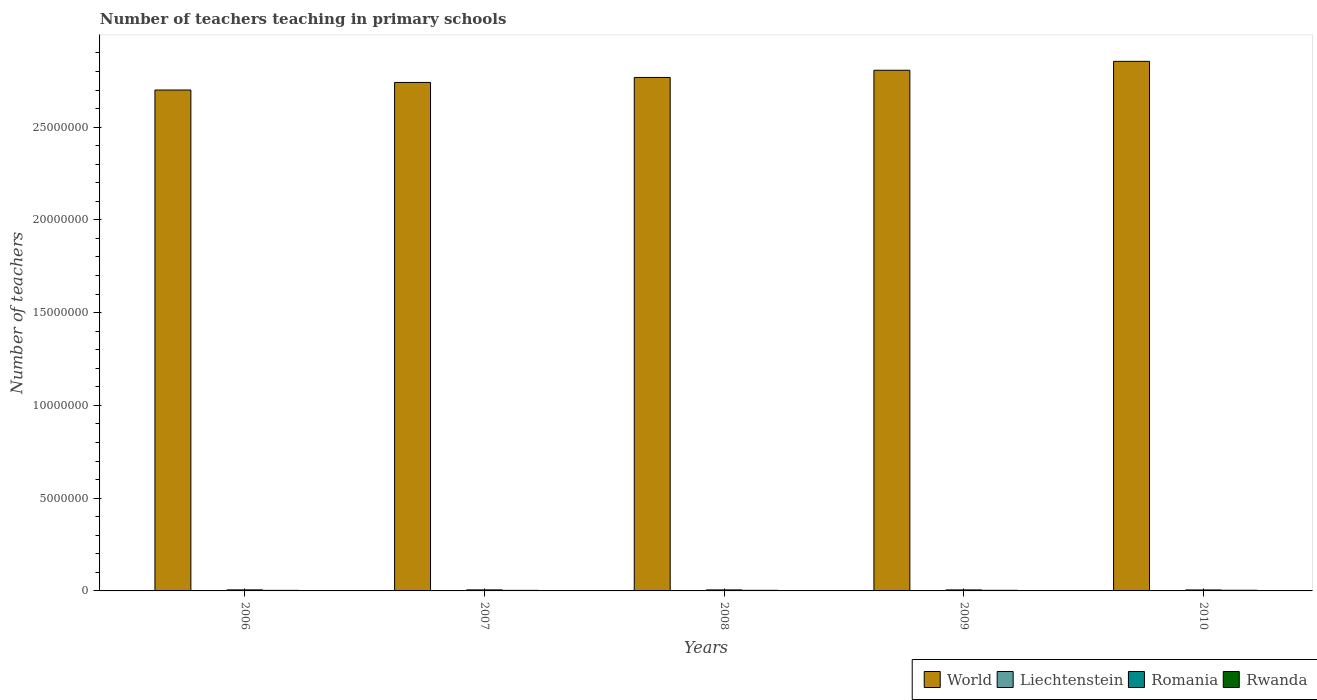How many different coloured bars are there?
Keep it short and to the point. 4. Are the number of bars per tick equal to the number of legend labels?
Your answer should be compact. Yes. Are the number of bars on each tick of the X-axis equal?
Your answer should be compact. Yes. How many bars are there on the 5th tick from the right?
Provide a succinct answer. 4. In how many cases, is the number of bars for a given year not equal to the number of legend labels?
Make the answer very short. 0. What is the number of teachers teaching in primary schools in Romania in 2009?
Provide a short and direct response. 5.41e+04. Across all years, what is the maximum number of teachers teaching in primary schools in Rwanda?
Give a very brief answer. 3.56e+04. Across all years, what is the minimum number of teachers teaching in primary schools in Liechtenstein?
Offer a terse response. 268. What is the total number of teachers teaching in primary schools in Romania in the graph?
Make the answer very short. 2.72e+05. What is the difference between the number of teachers teaching in primary schools in Romania in 2006 and that in 2007?
Make the answer very short. 334. What is the difference between the number of teachers teaching in primary schools in World in 2008 and the number of teachers teaching in primary schools in Liechtenstein in 2006?
Provide a short and direct response. 2.77e+07. What is the average number of teachers teaching in primary schools in Romania per year?
Keep it short and to the point. 5.44e+04. In the year 2007, what is the difference between the number of teachers teaching in primary schools in Liechtenstein and number of teachers teaching in primary schools in World?
Provide a succinct answer. -2.74e+07. In how many years, is the number of teachers teaching in primary schools in World greater than 25000000?
Keep it short and to the point. 5. What is the ratio of the number of teachers teaching in primary schools in World in 2007 to that in 2008?
Provide a succinct answer. 0.99. What is the difference between the highest and the second highest number of teachers teaching in primary schools in World?
Offer a terse response. 4.80e+05. What is the difference between the highest and the lowest number of teachers teaching in primary schools in Rwanda?
Your answer should be compact. 4946. What does the 3rd bar from the left in 2010 represents?
Offer a very short reply. Romania. Is it the case that in every year, the sum of the number of teachers teaching in primary schools in Romania and number of teachers teaching in primary schools in Rwanda is greater than the number of teachers teaching in primary schools in World?
Your answer should be very brief. No. How many bars are there?
Provide a succinct answer. 20. Are all the bars in the graph horizontal?
Your answer should be very brief. No. How many years are there in the graph?
Ensure brevity in your answer.  5. What is the difference between two consecutive major ticks on the Y-axis?
Your response must be concise. 5.00e+06. Does the graph contain any zero values?
Keep it short and to the point. No. Does the graph contain grids?
Your answer should be very brief. No. Where does the legend appear in the graph?
Offer a terse response. Bottom right. How are the legend labels stacked?
Make the answer very short. Horizontal. What is the title of the graph?
Keep it short and to the point. Number of teachers teaching in primary schools. Does "Congo (Democratic)" appear as one of the legend labels in the graph?
Provide a short and direct response. No. What is the label or title of the X-axis?
Give a very brief answer. Years. What is the label or title of the Y-axis?
Your answer should be very brief. Number of teachers. What is the Number of teachers of World in 2006?
Make the answer very short. 2.70e+07. What is the Number of teachers in Liechtenstein in 2006?
Keep it short and to the point. 268. What is the Number of teachers in Romania in 2006?
Provide a short and direct response. 5.58e+04. What is the Number of teachers of Rwanda in 2006?
Your answer should be very brief. 3.06e+04. What is the Number of teachers in World in 2007?
Keep it short and to the point. 2.74e+07. What is the Number of teachers in Liechtenstein in 2007?
Provide a short and direct response. 315. What is the Number of teachers in Romania in 2007?
Keep it short and to the point. 5.55e+04. What is the Number of teachers of Rwanda in 2007?
Provide a short and direct response. 3.10e+04. What is the Number of teachers of World in 2008?
Offer a terse response. 2.77e+07. What is the Number of teachers in Liechtenstein in 2008?
Keep it short and to the point. 332. What is the Number of teachers of Romania in 2008?
Ensure brevity in your answer.  5.46e+04. What is the Number of teachers of Rwanda in 2008?
Your answer should be compact. 3.23e+04. What is the Number of teachers in World in 2009?
Your response must be concise. 2.81e+07. What is the Number of teachers of Liechtenstein in 2009?
Keep it short and to the point. 328. What is the Number of teachers in Romania in 2009?
Offer a very short reply. 5.41e+04. What is the Number of teachers of Rwanda in 2009?
Your answer should be compact. 3.32e+04. What is the Number of teachers of World in 2010?
Provide a short and direct response. 2.85e+07. What is the Number of teachers of Liechtenstein in 2010?
Provide a succinct answer. 337. What is the Number of teachers of Romania in 2010?
Your answer should be very brief. 5.23e+04. What is the Number of teachers in Rwanda in 2010?
Offer a terse response. 3.56e+04. Across all years, what is the maximum Number of teachers of World?
Provide a succinct answer. 2.85e+07. Across all years, what is the maximum Number of teachers of Liechtenstein?
Give a very brief answer. 337. Across all years, what is the maximum Number of teachers of Romania?
Give a very brief answer. 5.58e+04. Across all years, what is the maximum Number of teachers in Rwanda?
Give a very brief answer. 3.56e+04. Across all years, what is the minimum Number of teachers in World?
Ensure brevity in your answer.  2.70e+07. Across all years, what is the minimum Number of teachers in Liechtenstein?
Ensure brevity in your answer.  268. Across all years, what is the minimum Number of teachers in Romania?
Your answer should be compact. 5.23e+04. Across all years, what is the minimum Number of teachers in Rwanda?
Provide a succinct answer. 3.06e+04. What is the total Number of teachers in World in the graph?
Ensure brevity in your answer.  1.39e+08. What is the total Number of teachers in Liechtenstein in the graph?
Keep it short and to the point. 1580. What is the total Number of teachers of Romania in the graph?
Offer a terse response. 2.72e+05. What is the total Number of teachers of Rwanda in the graph?
Your answer should be very brief. 1.63e+05. What is the difference between the Number of teachers in World in 2006 and that in 2007?
Offer a very short reply. -4.08e+05. What is the difference between the Number of teachers of Liechtenstein in 2006 and that in 2007?
Provide a succinct answer. -47. What is the difference between the Number of teachers in Romania in 2006 and that in 2007?
Keep it short and to the point. 334. What is the difference between the Number of teachers in Rwanda in 2006 and that in 2007?
Provide a succinct answer. -400. What is the difference between the Number of teachers of World in 2006 and that in 2008?
Provide a succinct answer. -6.77e+05. What is the difference between the Number of teachers in Liechtenstein in 2006 and that in 2008?
Your answer should be compact. -64. What is the difference between the Number of teachers in Romania in 2006 and that in 2008?
Offer a very short reply. 1271. What is the difference between the Number of teachers of Rwanda in 2006 and that in 2008?
Give a very brief answer. -1701. What is the difference between the Number of teachers in World in 2006 and that in 2009?
Provide a short and direct response. -1.06e+06. What is the difference between the Number of teachers of Liechtenstein in 2006 and that in 2009?
Ensure brevity in your answer.  -60. What is the difference between the Number of teachers in Romania in 2006 and that in 2009?
Keep it short and to the point. 1752. What is the difference between the Number of teachers of Rwanda in 2006 and that in 2009?
Keep it short and to the point. -2521. What is the difference between the Number of teachers in World in 2006 and that in 2010?
Ensure brevity in your answer.  -1.55e+06. What is the difference between the Number of teachers in Liechtenstein in 2006 and that in 2010?
Ensure brevity in your answer.  -69. What is the difference between the Number of teachers in Romania in 2006 and that in 2010?
Ensure brevity in your answer.  3549. What is the difference between the Number of teachers in Rwanda in 2006 and that in 2010?
Offer a terse response. -4946. What is the difference between the Number of teachers in World in 2007 and that in 2008?
Give a very brief answer. -2.69e+05. What is the difference between the Number of teachers of Romania in 2007 and that in 2008?
Give a very brief answer. 937. What is the difference between the Number of teachers of Rwanda in 2007 and that in 2008?
Keep it short and to the point. -1301. What is the difference between the Number of teachers in World in 2007 and that in 2009?
Offer a very short reply. -6.57e+05. What is the difference between the Number of teachers of Romania in 2007 and that in 2009?
Keep it short and to the point. 1418. What is the difference between the Number of teachers of Rwanda in 2007 and that in 2009?
Keep it short and to the point. -2121. What is the difference between the Number of teachers of World in 2007 and that in 2010?
Your answer should be compact. -1.14e+06. What is the difference between the Number of teachers of Liechtenstein in 2007 and that in 2010?
Your answer should be compact. -22. What is the difference between the Number of teachers in Romania in 2007 and that in 2010?
Keep it short and to the point. 3215. What is the difference between the Number of teachers in Rwanda in 2007 and that in 2010?
Provide a succinct answer. -4546. What is the difference between the Number of teachers of World in 2008 and that in 2009?
Your answer should be very brief. -3.88e+05. What is the difference between the Number of teachers in Liechtenstein in 2008 and that in 2009?
Provide a succinct answer. 4. What is the difference between the Number of teachers of Romania in 2008 and that in 2009?
Keep it short and to the point. 481. What is the difference between the Number of teachers of Rwanda in 2008 and that in 2009?
Offer a very short reply. -820. What is the difference between the Number of teachers in World in 2008 and that in 2010?
Offer a very short reply. -8.69e+05. What is the difference between the Number of teachers in Romania in 2008 and that in 2010?
Offer a very short reply. 2278. What is the difference between the Number of teachers in Rwanda in 2008 and that in 2010?
Provide a succinct answer. -3245. What is the difference between the Number of teachers in World in 2009 and that in 2010?
Provide a short and direct response. -4.80e+05. What is the difference between the Number of teachers of Romania in 2009 and that in 2010?
Offer a very short reply. 1797. What is the difference between the Number of teachers in Rwanda in 2009 and that in 2010?
Make the answer very short. -2425. What is the difference between the Number of teachers in World in 2006 and the Number of teachers in Liechtenstein in 2007?
Make the answer very short. 2.70e+07. What is the difference between the Number of teachers of World in 2006 and the Number of teachers of Romania in 2007?
Ensure brevity in your answer.  2.69e+07. What is the difference between the Number of teachers in World in 2006 and the Number of teachers in Rwanda in 2007?
Give a very brief answer. 2.70e+07. What is the difference between the Number of teachers in Liechtenstein in 2006 and the Number of teachers in Romania in 2007?
Your response must be concise. -5.52e+04. What is the difference between the Number of teachers of Liechtenstein in 2006 and the Number of teachers of Rwanda in 2007?
Ensure brevity in your answer.  -3.08e+04. What is the difference between the Number of teachers in Romania in 2006 and the Number of teachers in Rwanda in 2007?
Give a very brief answer. 2.48e+04. What is the difference between the Number of teachers of World in 2006 and the Number of teachers of Liechtenstein in 2008?
Keep it short and to the point. 2.70e+07. What is the difference between the Number of teachers of World in 2006 and the Number of teachers of Romania in 2008?
Your response must be concise. 2.69e+07. What is the difference between the Number of teachers of World in 2006 and the Number of teachers of Rwanda in 2008?
Make the answer very short. 2.70e+07. What is the difference between the Number of teachers of Liechtenstein in 2006 and the Number of teachers of Romania in 2008?
Your response must be concise. -5.43e+04. What is the difference between the Number of teachers in Liechtenstein in 2006 and the Number of teachers in Rwanda in 2008?
Offer a terse response. -3.21e+04. What is the difference between the Number of teachers of Romania in 2006 and the Number of teachers of Rwanda in 2008?
Give a very brief answer. 2.35e+04. What is the difference between the Number of teachers of World in 2006 and the Number of teachers of Liechtenstein in 2009?
Ensure brevity in your answer.  2.70e+07. What is the difference between the Number of teachers in World in 2006 and the Number of teachers in Romania in 2009?
Your answer should be compact. 2.69e+07. What is the difference between the Number of teachers in World in 2006 and the Number of teachers in Rwanda in 2009?
Your answer should be compact. 2.70e+07. What is the difference between the Number of teachers in Liechtenstein in 2006 and the Number of teachers in Romania in 2009?
Ensure brevity in your answer.  -5.38e+04. What is the difference between the Number of teachers in Liechtenstein in 2006 and the Number of teachers in Rwanda in 2009?
Keep it short and to the point. -3.29e+04. What is the difference between the Number of teachers of Romania in 2006 and the Number of teachers of Rwanda in 2009?
Keep it short and to the point. 2.27e+04. What is the difference between the Number of teachers in World in 2006 and the Number of teachers in Liechtenstein in 2010?
Offer a terse response. 2.70e+07. What is the difference between the Number of teachers of World in 2006 and the Number of teachers of Romania in 2010?
Provide a succinct answer. 2.69e+07. What is the difference between the Number of teachers in World in 2006 and the Number of teachers in Rwanda in 2010?
Provide a short and direct response. 2.70e+07. What is the difference between the Number of teachers of Liechtenstein in 2006 and the Number of teachers of Romania in 2010?
Your answer should be very brief. -5.20e+04. What is the difference between the Number of teachers of Liechtenstein in 2006 and the Number of teachers of Rwanda in 2010?
Your response must be concise. -3.53e+04. What is the difference between the Number of teachers in Romania in 2006 and the Number of teachers in Rwanda in 2010?
Your answer should be very brief. 2.02e+04. What is the difference between the Number of teachers in World in 2007 and the Number of teachers in Liechtenstein in 2008?
Provide a succinct answer. 2.74e+07. What is the difference between the Number of teachers of World in 2007 and the Number of teachers of Romania in 2008?
Your answer should be compact. 2.74e+07. What is the difference between the Number of teachers of World in 2007 and the Number of teachers of Rwanda in 2008?
Your answer should be very brief. 2.74e+07. What is the difference between the Number of teachers of Liechtenstein in 2007 and the Number of teachers of Romania in 2008?
Provide a short and direct response. -5.42e+04. What is the difference between the Number of teachers in Liechtenstein in 2007 and the Number of teachers in Rwanda in 2008?
Offer a terse response. -3.20e+04. What is the difference between the Number of teachers of Romania in 2007 and the Number of teachers of Rwanda in 2008?
Your answer should be very brief. 2.31e+04. What is the difference between the Number of teachers in World in 2007 and the Number of teachers in Liechtenstein in 2009?
Keep it short and to the point. 2.74e+07. What is the difference between the Number of teachers in World in 2007 and the Number of teachers in Romania in 2009?
Ensure brevity in your answer.  2.74e+07. What is the difference between the Number of teachers of World in 2007 and the Number of teachers of Rwanda in 2009?
Make the answer very short. 2.74e+07. What is the difference between the Number of teachers in Liechtenstein in 2007 and the Number of teachers in Romania in 2009?
Your answer should be very brief. -5.38e+04. What is the difference between the Number of teachers in Liechtenstein in 2007 and the Number of teachers in Rwanda in 2009?
Your answer should be very brief. -3.28e+04. What is the difference between the Number of teachers of Romania in 2007 and the Number of teachers of Rwanda in 2009?
Ensure brevity in your answer.  2.23e+04. What is the difference between the Number of teachers of World in 2007 and the Number of teachers of Liechtenstein in 2010?
Ensure brevity in your answer.  2.74e+07. What is the difference between the Number of teachers of World in 2007 and the Number of teachers of Romania in 2010?
Your response must be concise. 2.74e+07. What is the difference between the Number of teachers in World in 2007 and the Number of teachers in Rwanda in 2010?
Ensure brevity in your answer.  2.74e+07. What is the difference between the Number of teachers in Liechtenstein in 2007 and the Number of teachers in Romania in 2010?
Your answer should be compact. -5.20e+04. What is the difference between the Number of teachers of Liechtenstein in 2007 and the Number of teachers of Rwanda in 2010?
Give a very brief answer. -3.53e+04. What is the difference between the Number of teachers in Romania in 2007 and the Number of teachers in Rwanda in 2010?
Offer a terse response. 1.99e+04. What is the difference between the Number of teachers of World in 2008 and the Number of teachers of Liechtenstein in 2009?
Make the answer very short. 2.77e+07. What is the difference between the Number of teachers in World in 2008 and the Number of teachers in Romania in 2009?
Provide a succinct answer. 2.76e+07. What is the difference between the Number of teachers in World in 2008 and the Number of teachers in Rwanda in 2009?
Keep it short and to the point. 2.76e+07. What is the difference between the Number of teachers in Liechtenstein in 2008 and the Number of teachers in Romania in 2009?
Your response must be concise. -5.37e+04. What is the difference between the Number of teachers of Liechtenstein in 2008 and the Number of teachers of Rwanda in 2009?
Your answer should be very brief. -3.28e+04. What is the difference between the Number of teachers in Romania in 2008 and the Number of teachers in Rwanda in 2009?
Your answer should be compact. 2.14e+04. What is the difference between the Number of teachers in World in 2008 and the Number of teachers in Liechtenstein in 2010?
Provide a short and direct response. 2.77e+07. What is the difference between the Number of teachers of World in 2008 and the Number of teachers of Romania in 2010?
Ensure brevity in your answer.  2.76e+07. What is the difference between the Number of teachers in World in 2008 and the Number of teachers in Rwanda in 2010?
Offer a terse response. 2.76e+07. What is the difference between the Number of teachers of Liechtenstein in 2008 and the Number of teachers of Romania in 2010?
Provide a short and direct response. -5.19e+04. What is the difference between the Number of teachers in Liechtenstein in 2008 and the Number of teachers in Rwanda in 2010?
Give a very brief answer. -3.53e+04. What is the difference between the Number of teachers of Romania in 2008 and the Number of teachers of Rwanda in 2010?
Provide a short and direct response. 1.90e+04. What is the difference between the Number of teachers of World in 2009 and the Number of teachers of Liechtenstein in 2010?
Your answer should be very brief. 2.81e+07. What is the difference between the Number of teachers of World in 2009 and the Number of teachers of Romania in 2010?
Provide a short and direct response. 2.80e+07. What is the difference between the Number of teachers of World in 2009 and the Number of teachers of Rwanda in 2010?
Offer a terse response. 2.80e+07. What is the difference between the Number of teachers in Liechtenstein in 2009 and the Number of teachers in Romania in 2010?
Offer a very short reply. -5.19e+04. What is the difference between the Number of teachers in Liechtenstein in 2009 and the Number of teachers in Rwanda in 2010?
Ensure brevity in your answer.  -3.53e+04. What is the difference between the Number of teachers of Romania in 2009 and the Number of teachers of Rwanda in 2010?
Provide a short and direct response. 1.85e+04. What is the average Number of teachers in World per year?
Offer a terse response. 2.77e+07. What is the average Number of teachers of Liechtenstein per year?
Your answer should be very brief. 316. What is the average Number of teachers of Romania per year?
Keep it short and to the point. 5.44e+04. What is the average Number of teachers of Rwanda per year?
Your answer should be compact. 3.26e+04. In the year 2006, what is the difference between the Number of teachers of World and Number of teachers of Liechtenstein?
Your answer should be very brief. 2.70e+07. In the year 2006, what is the difference between the Number of teachers of World and Number of teachers of Romania?
Offer a terse response. 2.69e+07. In the year 2006, what is the difference between the Number of teachers of World and Number of teachers of Rwanda?
Offer a terse response. 2.70e+07. In the year 2006, what is the difference between the Number of teachers of Liechtenstein and Number of teachers of Romania?
Your answer should be compact. -5.56e+04. In the year 2006, what is the difference between the Number of teachers of Liechtenstein and Number of teachers of Rwanda?
Provide a succinct answer. -3.04e+04. In the year 2006, what is the difference between the Number of teachers of Romania and Number of teachers of Rwanda?
Your answer should be compact. 2.52e+04. In the year 2007, what is the difference between the Number of teachers in World and Number of teachers in Liechtenstein?
Offer a very short reply. 2.74e+07. In the year 2007, what is the difference between the Number of teachers in World and Number of teachers in Romania?
Provide a short and direct response. 2.74e+07. In the year 2007, what is the difference between the Number of teachers of World and Number of teachers of Rwanda?
Offer a terse response. 2.74e+07. In the year 2007, what is the difference between the Number of teachers in Liechtenstein and Number of teachers in Romania?
Your answer should be compact. -5.52e+04. In the year 2007, what is the difference between the Number of teachers in Liechtenstein and Number of teachers in Rwanda?
Offer a terse response. -3.07e+04. In the year 2007, what is the difference between the Number of teachers of Romania and Number of teachers of Rwanda?
Give a very brief answer. 2.44e+04. In the year 2008, what is the difference between the Number of teachers of World and Number of teachers of Liechtenstein?
Your response must be concise. 2.77e+07. In the year 2008, what is the difference between the Number of teachers of World and Number of teachers of Romania?
Offer a very short reply. 2.76e+07. In the year 2008, what is the difference between the Number of teachers in World and Number of teachers in Rwanda?
Your answer should be compact. 2.76e+07. In the year 2008, what is the difference between the Number of teachers of Liechtenstein and Number of teachers of Romania?
Your response must be concise. -5.42e+04. In the year 2008, what is the difference between the Number of teachers of Liechtenstein and Number of teachers of Rwanda?
Make the answer very short. -3.20e+04. In the year 2008, what is the difference between the Number of teachers in Romania and Number of teachers in Rwanda?
Keep it short and to the point. 2.22e+04. In the year 2009, what is the difference between the Number of teachers of World and Number of teachers of Liechtenstein?
Offer a very short reply. 2.81e+07. In the year 2009, what is the difference between the Number of teachers of World and Number of teachers of Romania?
Provide a succinct answer. 2.80e+07. In the year 2009, what is the difference between the Number of teachers in World and Number of teachers in Rwanda?
Give a very brief answer. 2.80e+07. In the year 2009, what is the difference between the Number of teachers in Liechtenstein and Number of teachers in Romania?
Offer a terse response. -5.37e+04. In the year 2009, what is the difference between the Number of teachers of Liechtenstein and Number of teachers of Rwanda?
Provide a succinct answer. -3.28e+04. In the year 2009, what is the difference between the Number of teachers in Romania and Number of teachers in Rwanda?
Offer a very short reply. 2.09e+04. In the year 2010, what is the difference between the Number of teachers of World and Number of teachers of Liechtenstein?
Offer a terse response. 2.85e+07. In the year 2010, what is the difference between the Number of teachers in World and Number of teachers in Romania?
Your answer should be very brief. 2.85e+07. In the year 2010, what is the difference between the Number of teachers in World and Number of teachers in Rwanda?
Offer a terse response. 2.85e+07. In the year 2010, what is the difference between the Number of teachers in Liechtenstein and Number of teachers in Romania?
Offer a very short reply. -5.19e+04. In the year 2010, what is the difference between the Number of teachers of Liechtenstein and Number of teachers of Rwanda?
Your answer should be compact. -3.52e+04. In the year 2010, what is the difference between the Number of teachers in Romania and Number of teachers in Rwanda?
Offer a terse response. 1.67e+04. What is the ratio of the Number of teachers in World in 2006 to that in 2007?
Keep it short and to the point. 0.99. What is the ratio of the Number of teachers of Liechtenstein in 2006 to that in 2007?
Your answer should be compact. 0.85. What is the ratio of the Number of teachers of Rwanda in 2006 to that in 2007?
Give a very brief answer. 0.99. What is the ratio of the Number of teachers in World in 2006 to that in 2008?
Ensure brevity in your answer.  0.98. What is the ratio of the Number of teachers in Liechtenstein in 2006 to that in 2008?
Offer a very short reply. 0.81. What is the ratio of the Number of teachers of Romania in 2006 to that in 2008?
Offer a terse response. 1.02. What is the ratio of the Number of teachers of World in 2006 to that in 2009?
Provide a succinct answer. 0.96. What is the ratio of the Number of teachers in Liechtenstein in 2006 to that in 2009?
Provide a short and direct response. 0.82. What is the ratio of the Number of teachers in Romania in 2006 to that in 2009?
Make the answer very short. 1.03. What is the ratio of the Number of teachers of Rwanda in 2006 to that in 2009?
Make the answer very short. 0.92. What is the ratio of the Number of teachers of World in 2006 to that in 2010?
Provide a succinct answer. 0.95. What is the ratio of the Number of teachers in Liechtenstein in 2006 to that in 2010?
Give a very brief answer. 0.8. What is the ratio of the Number of teachers in Romania in 2006 to that in 2010?
Keep it short and to the point. 1.07. What is the ratio of the Number of teachers in Rwanda in 2006 to that in 2010?
Your response must be concise. 0.86. What is the ratio of the Number of teachers of World in 2007 to that in 2008?
Your answer should be compact. 0.99. What is the ratio of the Number of teachers of Liechtenstein in 2007 to that in 2008?
Ensure brevity in your answer.  0.95. What is the ratio of the Number of teachers of Romania in 2007 to that in 2008?
Your answer should be very brief. 1.02. What is the ratio of the Number of teachers in Rwanda in 2007 to that in 2008?
Provide a short and direct response. 0.96. What is the ratio of the Number of teachers in World in 2007 to that in 2009?
Keep it short and to the point. 0.98. What is the ratio of the Number of teachers in Liechtenstein in 2007 to that in 2009?
Make the answer very short. 0.96. What is the ratio of the Number of teachers in Romania in 2007 to that in 2009?
Offer a terse response. 1.03. What is the ratio of the Number of teachers of Rwanda in 2007 to that in 2009?
Make the answer very short. 0.94. What is the ratio of the Number of teachers in World in 2007 to that in 2010?
Make the answer very short. 0.96. What is the ratio of the Number of teachers of Liechtenstein in 2007 to that in 2010?
Keep it short and to the point. 0.93. What is the ratio of the Number of teachers of Romania in 2007 to that in 2010?
Your response must be concise. 1.06. What is the ratio of the Number of teachers of Rwanda in 2007 to that in 2010?
Your response must be concise. 0.87. What is the ratio of the Number of teachers of World in 2008 to that in 2009?
Ensure brevity in your answer.  0.99. What is the ratio of the Number of teachers of Liechtenstein in 2008 to that in 2009?
Keep it short and to the point. 1.01. What is the ratio of the Number of teachers of Romania in 2008 to that in 2009?
Your response must be concise. 1.01. What is the ratio of the Number of teachers in Rwanda in 2008 to that in 2009?
Provide a succinct answer. 0.98. What is the ratio of the Number of teachers of World in 2008 to that in 2010?
Provide a succinct answer. 0.97. What is the ratio of the Number of teachers in Liechtenstein in 2008 to that in 2010?
Make the answer very short. 0.99. What is the ratio of the Number of teachers of Romania in 2008 to that in 2010?
Your answer should be compact. 1.04. What is the ratio of the Number of teachers of Rwanda in 2008 to that in 2010?
Provide a succinct answer. 0.91. What is the ratio of the Number of teachers in World in 2009 to that in 2010?
Provide a short and direct response. 0.98. What is the ratio of the Number of teachers in Liechtenstein in 2009 to that in 2010?
Your answer should be compact. 0.97. What is the ratio of the Number of teachers of Romania in 2009 to that in 2010?
Your response must be concise. 1.03. What is the ratio of the Number of teachers of Rwanda in 2009 to that in 2010?
Make the answer very short. 0.93. What is the difference between the highest and the second highest Number of teachers of World?
Provide a short and direct response. 4.80e+05. What is the difference between the highest and the second highest Number of teachers of Romania?
Your response must be concise. 334. What is the difference between the highest and the second highest Number of teachers in Rwanda?
Provide a succinct answer. 2425. What is the difference between the highest and the lowest Number of teachers of World?
Offer a terse response. 1.55e+06. What is the difference between the highest and the lowest Number of teachers of Liechtenstein?
Provide a short and direct response. 69. What is the difference between the highest and the lowest Number of teachers of Romania?
Your answer should be very brief. 3549. What is the difference between the highest and the lowest Number of teachers of Rwanda?
Provide a short and direct response. 4946. 